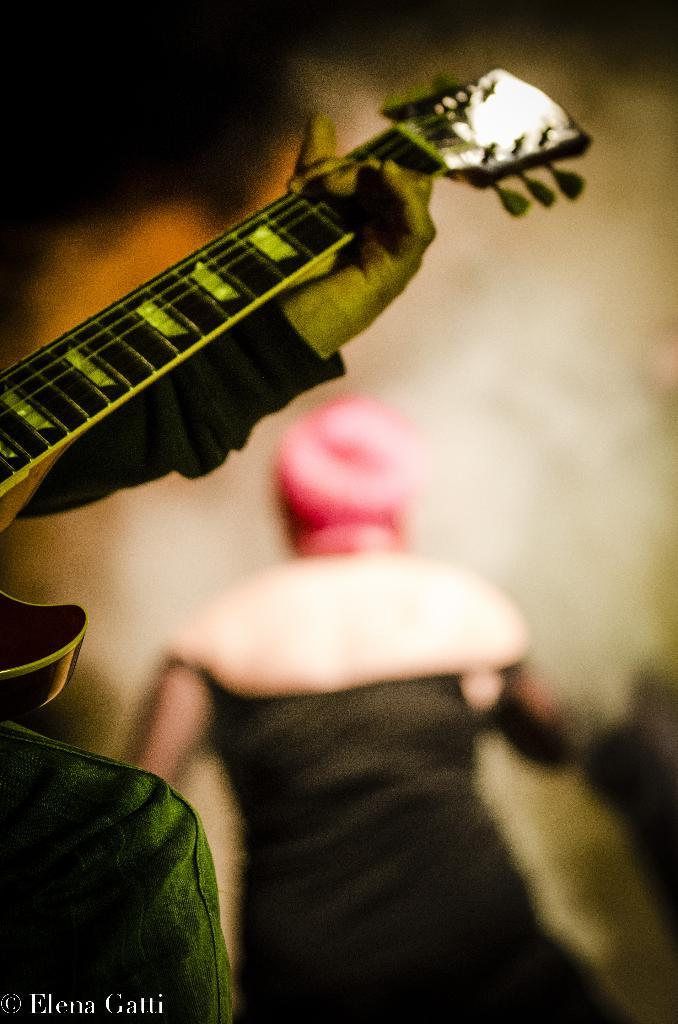How many people are in the image? There are two persons in the image. What is the position of one of the persons? One person is standing. What is the other person holding? The other person is holding a guitar. What type of pail is being used to test the watch in the image? There is no pail, test, or watch present in the image. 